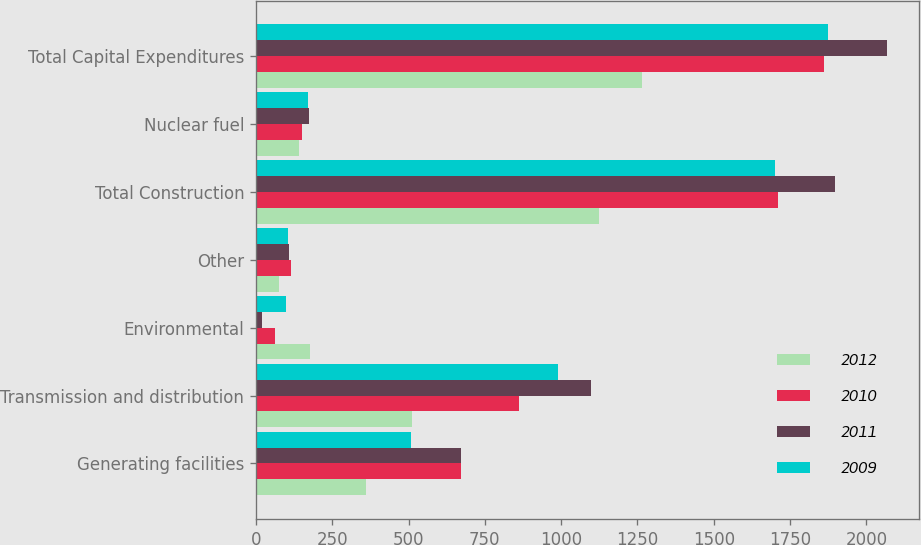Convert chart to OTSL. <chart><loc_0><loc_0><loc_500><loc_500><stacked_bar_chart><ecel><fcel>Generating facilities<fcel>Transmission and distribution<fcel>Environmental<fcel>Other<fcel>Total Construction<fcel>Nuclear fuel<fcel>Total Capital Expenditures<nl><fcel>2012<fcel>361<fcel>511<fcel>178<fcel>75<fcel>1125<fcel>140<fcel>1265<nl><fcel>2010<fcel>671<fcel>862<fcel>63<fcel>114<fcel>1710<fcel>151<fcel>1861<nl><fcel>2011<fcel>673<fcel>1097<fcel>19<fcel>107<fcel>1896<fcel>173<fcel>2069<nl><fcel>2009<fcel>507<fcel>990<fcel>99<fcel>106<fcel>1702<fcel>171<fcel>1873<nl></chart> 